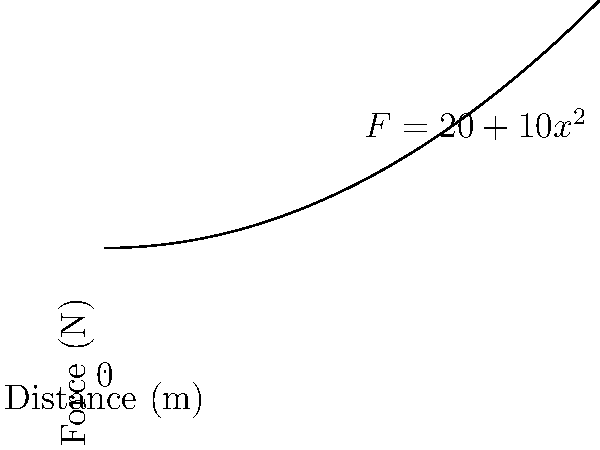A resistance band exercise involves stretching the band from 0 to 2 meters. The force (in Newtons) required to stretch the band is given by the function $F(x) = 20 + 10x^2$, where $x$ is the distance stretched in meters. Calculate the total work done in completing one repetition of this exercise. To calculate the work done, we need to integrate the force function over the distance:

1) The work done is given by the integral:
   $W = \int_{0}^{2} F(x) dx$

2) Substitute the force function:
   $W = \int_{0}^{2} (20 + 10x^2) dx$

3) Integrate:
   $W = [20x + \frac{10}{3}x^3]_{0}^{2}$

4) Evaluate the integral:
   $W = (40 + \frac{80}{3}) - (0 + 0)$

5) Simplify:
   $W = 40 + \frac{80}{3} = \frac{120 + 80}{3} = \frac{200}{3}$

6) Convert to a decimal:
   $W \approx 66.67$ J

Therefore, the total work done is approximately 66.67 Joules.
Answer: $\frac{200}{3}$ J or 66.67 J 